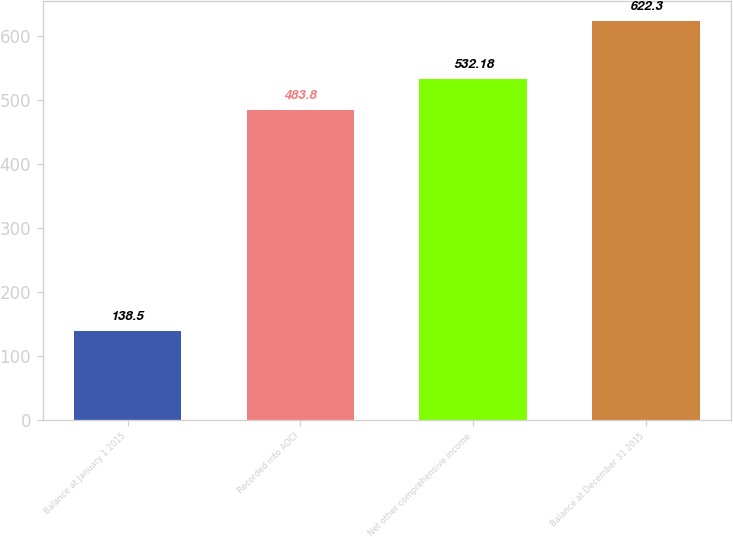Convert chart. <chart><loc_0><loc_0><loc_500><loc_500><bar_chart><fcel>Balance at January 1 2015<fcel>Recorded into AOCI<fcel>Net other comprehensive income<fcel>Balance at December 31 2015<nl><fcel>138.5<fcel>483.8<fcel>532.18<fcel>622.3<nl></chart> 